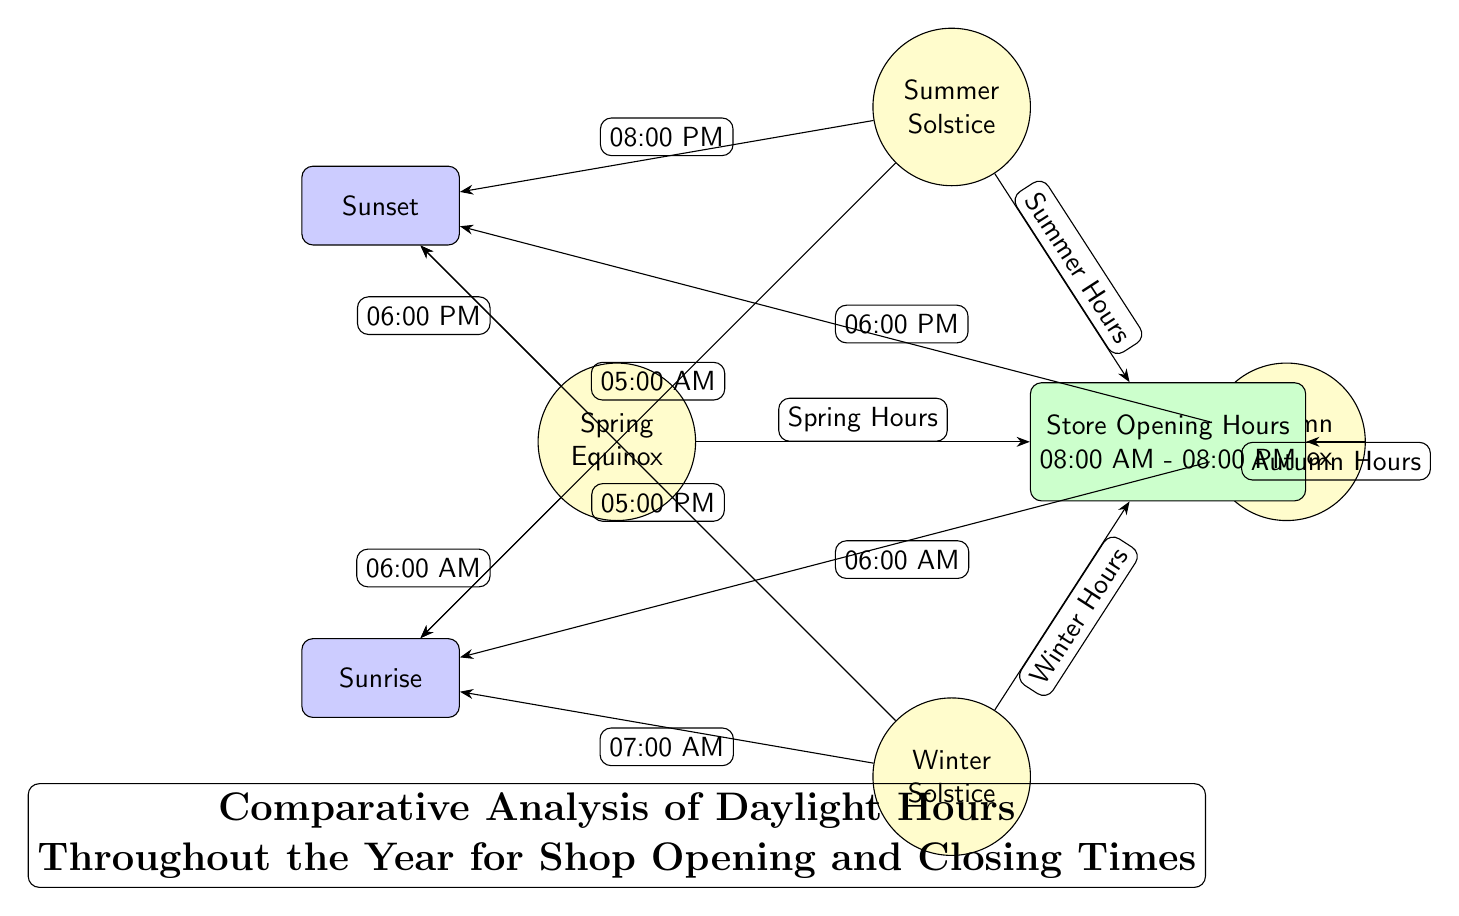What are the store opening hours indicated in the diagram? The diagram shows the store opening hours as 08:00 AM to 08:00 PM. This information is located in the "Store Opening Hours" node.
Answer: 08:00 AM - 08:00 PM At what time does the sun rise during the summer solstice? The diagram indicates that during the summer solstice, the sun rises at 05:00 AM, which is pointed out in the directed connection from the summer node to the sunrise node.
Answer: 05:00 AM How many seasons are represented in the diagram? The diagram includes four nodes representing the seasons: Spring Equinox, Summer Solstice, Autumn Equinox, and Winter Solstice. Counting these nodes gives a total of four seasons.
Answer: 4 What are the sunrise and sunset times during the winter solstice? The diagram shows sunrise at 07:00 AM and sunset at 05:00 PM for the winter solstice. These times are indicated by the directed connections from the winter node to the respective sunrise and sunset nodes.
Answer: 07:00 AM, 05:00 PM Which season has the latest sunset time? By comparing the sunset times from each season’s connections, the summer solstice shows the latest sunset time at 08:00 PM. This requires evaluating the sunset times of all four seasons.
Answer: 08:00 PM What is the sunrise time during the spring equinox? According to the diagram, the sunrise time for the spring equinox is 06:00 AM, as indicated by the directed connection from the spring node to the sunrise node.
Answer: 06:00 AM Which two seasons share the same sunset time? Examining the sunset times in the diagram, both spring and autumn equinoxes share the same sunset time of 06:00 PM. This is determined by looking for matching sunset times among the seasons.
Answer: Spring, Autumn What is the primary purpose of this diagram? The title at the bottom of the diagram specifies that its purpose is to provide a comparative analysis of daylight hours throughout the year for shop opening and closing times. This information encapsulates the overall intent of the visualization.
Answer: Comparative Analysis of Daylight Hours 